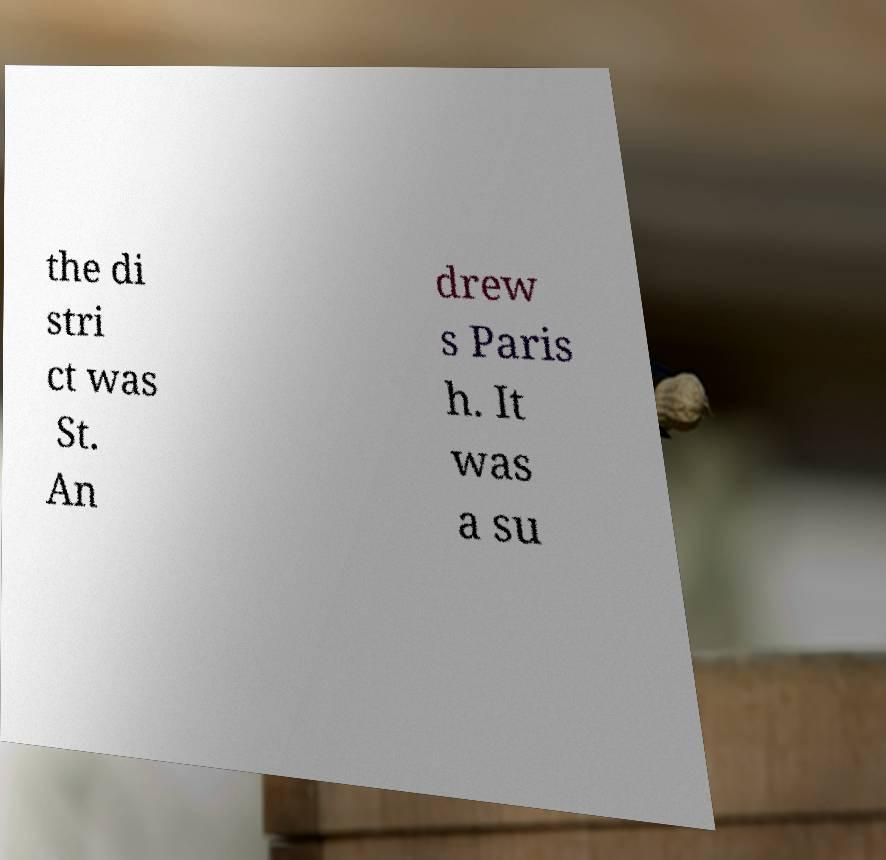Can you accurately transcribe the text from the provided image for me? the di stri ct was St. An drew s Paris h. It was a su 